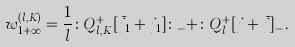<formula> <loc_0><loc_0><loc_500><loc_500>w _ { 1 + \infty } ^ { ( l , K ) } = \frac { 1 } { l } \colon Q _ { l , K } ^ { + } [ \bar { j } _ { 1 } + j _ { 1 } ] \colon _ { - } + \colon Q _ { l } ^ { + } [ j + \bar { j } ] _ { - } .</formula> 